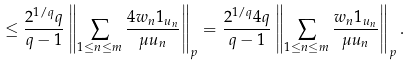<formula> <loc_0><loc_0><loc_500><loc_500>\leq \frac { 2 ^ { 1 / q } q } { q - 1 } \left \| \sum _ { 1 \leq n \leq m } \frac { 4 w _ { n } 1 _ { u _ { n } } } { \mu u _ { n } } \right \| _ { p } = \frac { 2 ^ { 1 / q } 4 q } { q - 1 } \left \| \sum _ { 1 \leq n \leq m } \frac { w _ { n } 1 _ { u _ { n } } } { \mu u _ { n } } \right \| _ { p } .</formula> 